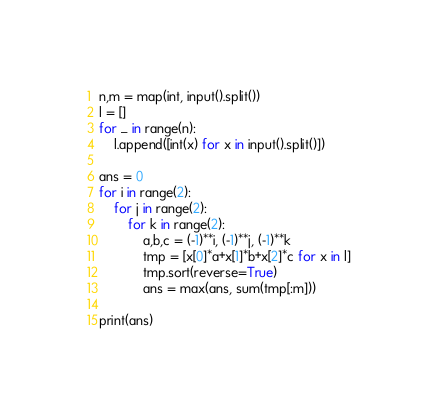<code> <loc_0><loc_0><loc_500><loc_500><_Python_>n,m = map(int, input().split())
l = []
for _ in range(n):
    l.append([int(x) for x in input().split()])

ans = 0
for i in range(2):
    for j in range(2):
        for k in range(2):
            a,b,c = (-1)**i, (-1)**j, (-1)**k
            tmp = [x[0]*a+x[1]*b+x[2]*c for x in l]
            tmp.sort(reverse=True)
            ans = max(ans, sum(tmp[:m]))

print(ans)</code> 